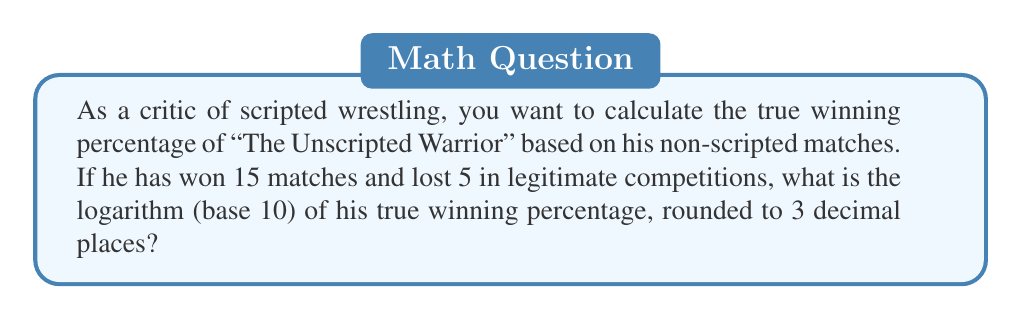Teach me how to tackle this problem. To solve this problem, we'll follow these steps:

1. Calculate the true winning percentage:
   Total matches = Wins + Losses = 15 + 5 = 20
   Winning percentage = $\frac{\text{Wins}}{\text{Total matches}} = \frac{15}{20} = 0.75$ or 75%

2. Convert the percentage to a decimal:
   0.75

3. Calculate the logarithm (base 10) of 0.75:
   $\log_{10}(0.75)$

4. Use a calculator or logarithm tables to compute:
   $\log_{10}(0.75) \approx -0.12493873$

5. Round the result to 3 decimal places:
   $-0.125$

Therefore, the logarithm (base 10) of "The Unscripted Warrior's" true winning percentage, rounded to 3 decimal places, is $-0.125$.
Answer: $-0.125$ 